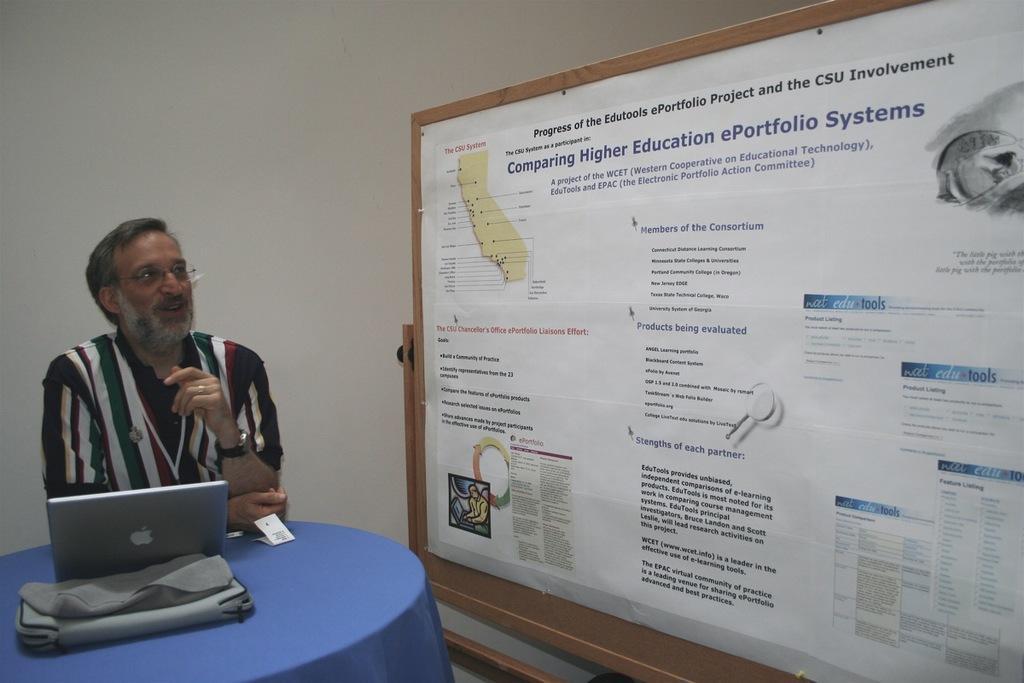Please provide a concise description of this image. In this image on the left there is a man, he wears a shirt, in front of him there is a table on that there is a bag and laptop. On the right there is a board, poster, text and images. In the background there is wall. 